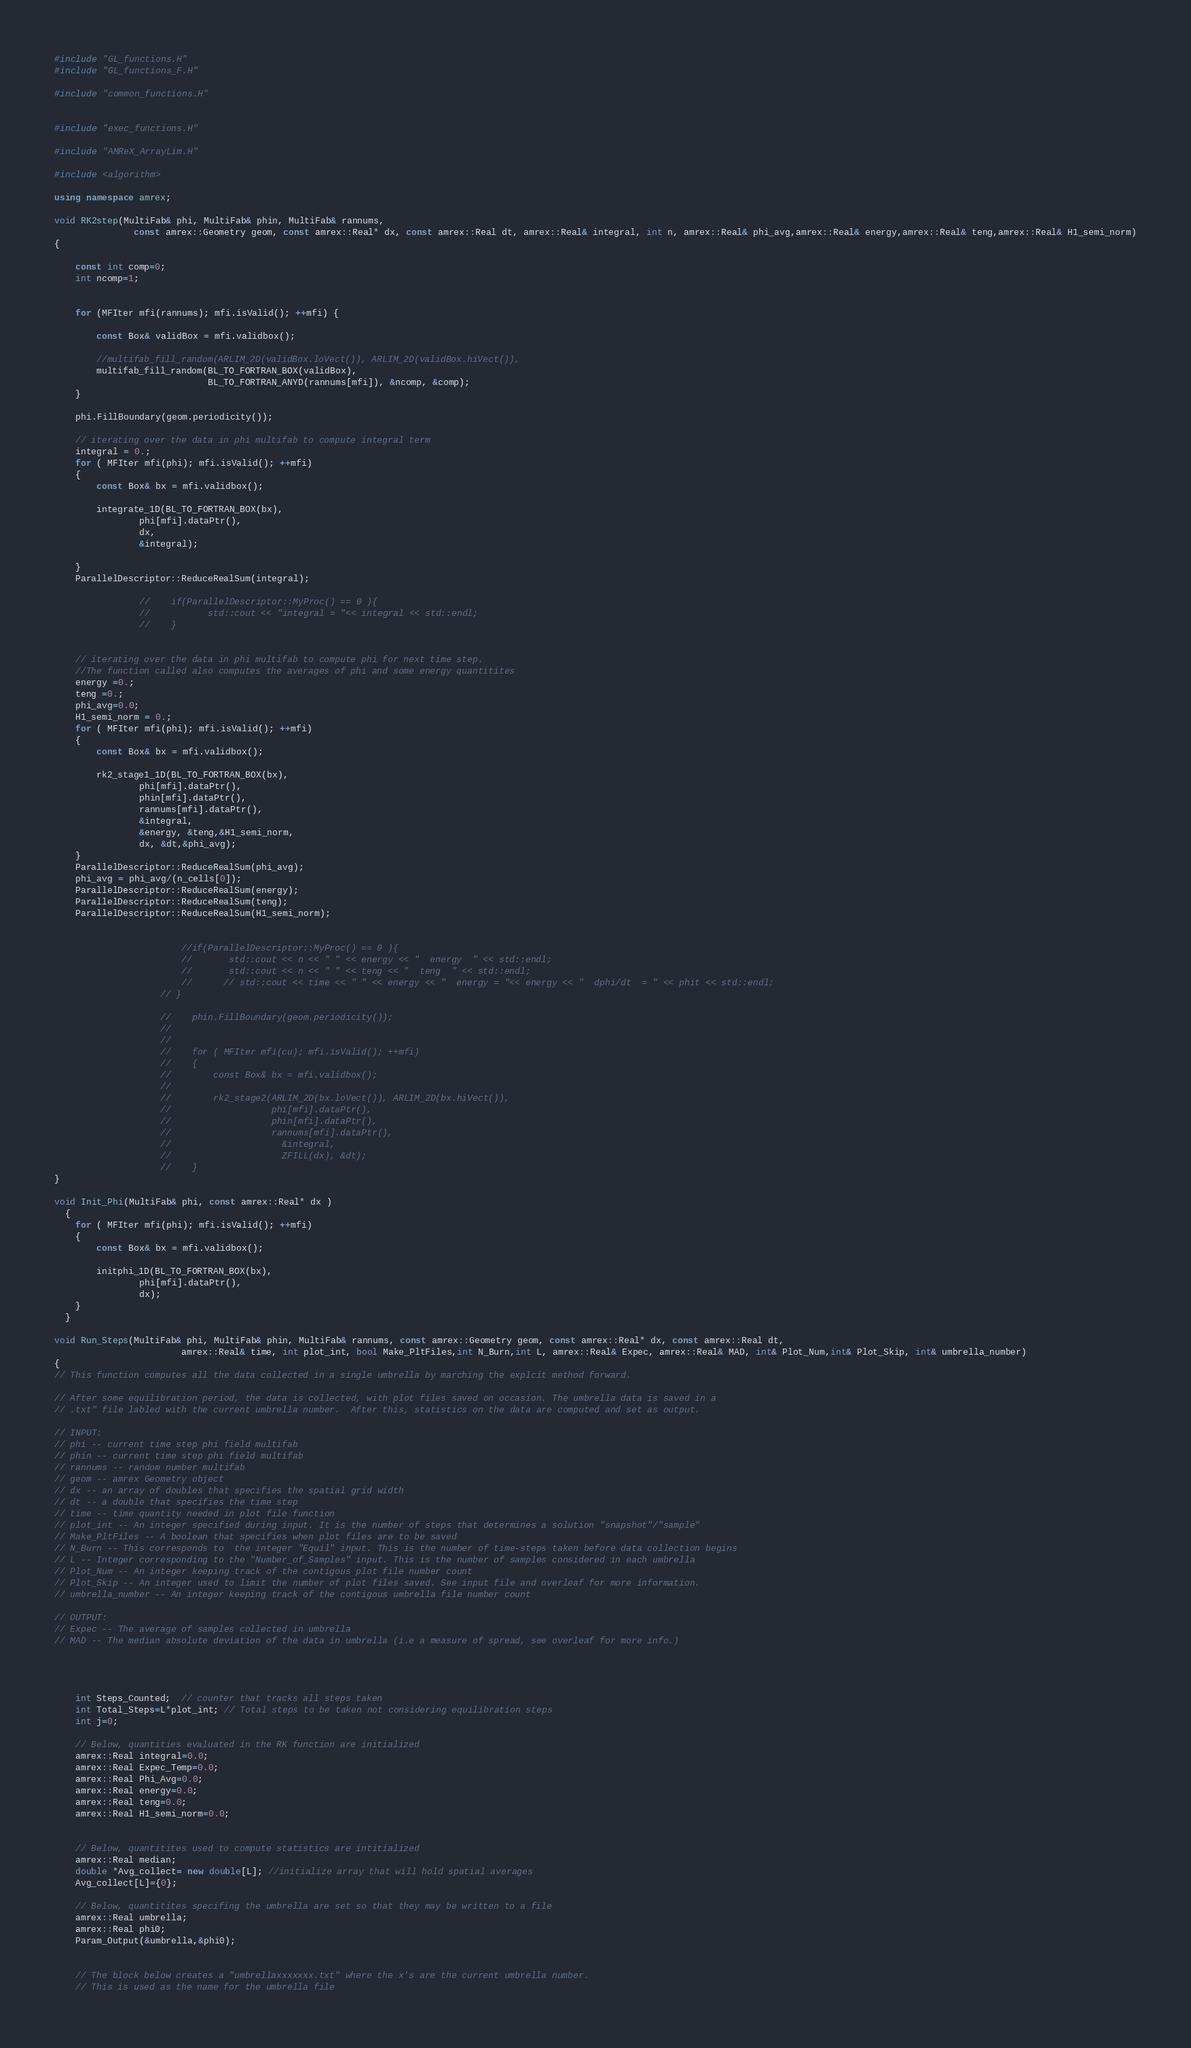<code> <loc_0><loc_0><loc_500><loc_500><_C++_>

#include "GL_functions.H"
#include "GL_functions_F.H"

#include "common_functions.H"


#include "exec_functions.H"

#include "AMReX_ArrayLim.H"

#include <algorithm>

using namespace amrex;

void RK2step(MultiFab& phi, MultiFab& phin, MultiFab& rannums, 
               const amrex::Geometry geom, const amrex::Real* dx, const amrex::Real dt, amrex::Real& integral, int n, amrex::Real& phi_avg,amrex::Real& energy,amrex::Real& teng,amrex::Real& H1_semi_norm)
{

    const int comp=0;
    int ncomp=1;


    for (MFIter mfi(rannums); mfi.isValid(); ++mfi) {

        const Box& validBox = mfi.validbox();

        //multifab_fill_random(ARLIM_2D(validBox.loVect()), ARLIM_2D(validBox.hiVect()),
        multifab_fill_random(BL_TO_FORTRAN_BOX(validBox),
                             BL_TO_FORTRAN_ANYD(rannums[mfi]), &ncomp, &comp);
    }

    phi.FillBoundary(geom.periodicity());

    // iterating over the data in phi multifab to compute integral term
    integral = 0.;
    for ( MFIter mfi(phi); mfi.isValid(); ++mfi)
    {
        const Box& bx = mfi.validbox();

        integrate_1D(BL_TO_FORTRAN_BOX(bx),
                phi[mfi].dataPtr(),  
                dx,
                &integral);   

    }
    ParallelDescriptor::ReduceRealSum(integral);

                //    if(ParallelDescriptor::MyProc() == 0 ){
                //           std::cout << "integral = "<< integral << std::endl;
                //    }


    // iterating over the data in phi multifab to compute phi for next time step. 
    //The function called also computes the averages of phi and some energy quantitites
    energy =0.;
    teng =0.;
    phi_avg=0.0;
    H1_semi_norm = 0.;
    for ( MFIter mfi(phi); mfi.isValid(); ++mfi)
    {
        const Box& bx = mfi.validbox();

        rk2_stage1_1D(BL_TO_FORTRAN_BOX(bx),
                phi[mfi].dataPtr(),  
                phin[mfi].dataPtr(),  
                rannums[mfi].dataPtr(),
                &integral,
                &energy, &teng,&H1_semi_norm,
                dx, &dt,&phi_avg);   
    }
    ParallelDescriptor::ReduceRealSum(phi_avg);
    phi_avg = phi_avg/(n_cells[0]);
    ParallelDescriptor::ReduceRealSum(energy);
    ParallelDescriptor::ReduceRealSum(teng);
    ParallelDescriptor::ReduceRealSum(H1_semi_norm);


                        //if(ParallelDescriptor::MyProc() == 0 ){
                        //       std::cout << n << " " << energy << "  energy  " << std::endl;
                        //       std::cout << n << " " << teng << "  teng  " << std::endl;
                        //      // std::cout << time << " " << energy << "  energy = "<< energy << "  dphi/dt  = " << phit << std::endl;
                    // }

                    //    phin.FillBoundary(geom.periodicity());
                    //
                    //
                    //    for ( MFIter mfi(cu); mfi.isValid(); ++mfi)
                    //    {
                    //        const Box& bx = mfi.validbox();
                    //
                    //        rk2_stage2(ARLIM_2D(bx.loVect()), ARLIM_2D(bx.hiVect()),
                    //                   phi[mfi].dataPtr(),  
                    //                   phin[mfi].dataPtr(),  
                    //                   rannums[mfi].dataPtr(),
                    //                     &integral,
                    //      	           ZFILL(dx), &dt);
                    //    }
}

void Init_Phi(MultiFab& phi, const amrex::Real* dx )
  {
    for ( MFIter mfi(phi); mfi.isValid(); ++mfi)
    {
        const Box& bx = mfi.validbox();

        initphi_1D(BL_TO_FORTRAN_BOX(bx),
                phi[mfi].dataPtr(),
                dx);
    }
  }

void Run_Steps(MultiFab& phi, MultiFab& phin, MultiFab& rannums, const amrex::Geometry geom, const amrex::Real* dx, const amrex::Real dt,
                        amrex::Real& time, int plot_int, bool Make_PltFiles,int N_Burn,int L, amrex::Real& Expec, amrex::Real& MAD, int& Plot_Num,int& Plot_Skip, int& umbrella_number)
{
// This function computes all the data collected in a single umbrella by marching the explcit method forward. 

// After some equilibration period, the data is collected, with plot files saved on occasion. The umbrella data is saved in a
// .txt" file labled with the current umbrella number.  After this, statistics on the data are computed and set as output. 

// INPUT:
// phi -- current time step phi field multifab
// phin -- current time step phi field multifab
// rannums -- random number multifab
// geom -- amrex Geometry object
// dx -- an array of doubles that specifies the spatial grid width 
// dt -- a double that specifies the time step
// time -- time quantity needed in plot file function
// plot_int -- An integer specified during input. It is the number of steps that determines a solution "snapshot"/"sample"
// Make_PltFiles -- A boolean that specifies when plot files are to be saved
// N_Burn -- This corresponds to  the integer "Equil" input. This is the number of time-steps taken before data collection begins
// L -- Integer corresponding to the "Number_of_Samples" input. This is the number of samples considered in each umbrella
// Plot_Num -- An integer keeping track of the contigous plot file number count
// Plot_Skip -- An integer used to limit the number of plot files saved. See input file and overleaf for more information. 
// umbrella_number -- An integer keeping track of the contigous umbrella file number count

// OUTPUT:
// Expec -- The average of samples collected in umbrella
// MAD -- The median absolute deviation of the data in umbrella (i.e a measure of spread, see overleaf for more info.)




    int Steps_Counted;  // counter that tracks all steps taken
    int Total_Steps=L*plot_int; // Total steps to be taken not considering equilibration steps
    int j=0;

    // Below, quantities evaluated in the RK function are initialized
    amrex::Real integral=0.0;
    amrex::Real Expec_Temp=0.0;
    amrex::Real Phi_Avg=0.0;
    amrex::Real energy=0.0;
    amrex::Real teng=0.0;
    amrex::Real H1_semi_norm=0.0;


    // Below, quantitites used to compute statistics are intitialized
    amrex::Real median;
    double *Avg_collect= new double[L]; //initialize array that will hold spatial averages
    Avg_collect[L]={0};

    // Below, quantitites specifing the umbrella are set so that they may be written to a file
    amrex::Real umbrella;
    amrex::Real phi0;
    Param_Output(&umbrella,&phi0);


    // The block below creates a "umbrellaxxxxxxx.txt" where the x's are the current umbrella number. 
    // This is used as the name for the umbrella file </code> 